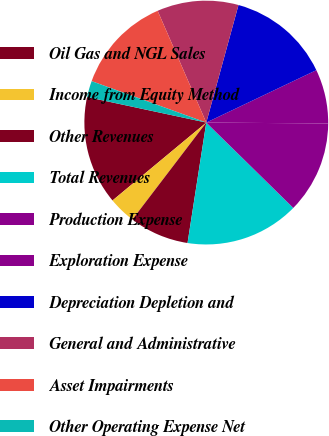<chart> <loc_0><loc_0><loc_500><loc_500><pie_chart><fcel>Oil Gas and NGL Sales<fcel>Income from Equity Method<fcel>Other Revenues<fcel>Total Revenues<fcel>Production Expense<fcel>Exploration Expense<fcel>Depreciation Depletion and<fcel>General and Administrative<fcel>Asset Impairments<fcel>Other Operating Expense Net<nl><fcel>14.39%<fcel>3.6%<fcel>7.91%<fcel>15.11%<fcel>12.23%<fcel>7.19%<fcel>13.67%<fcel>10.79%<fcel>12.95%<fcel>2.16%<nl></chart> 